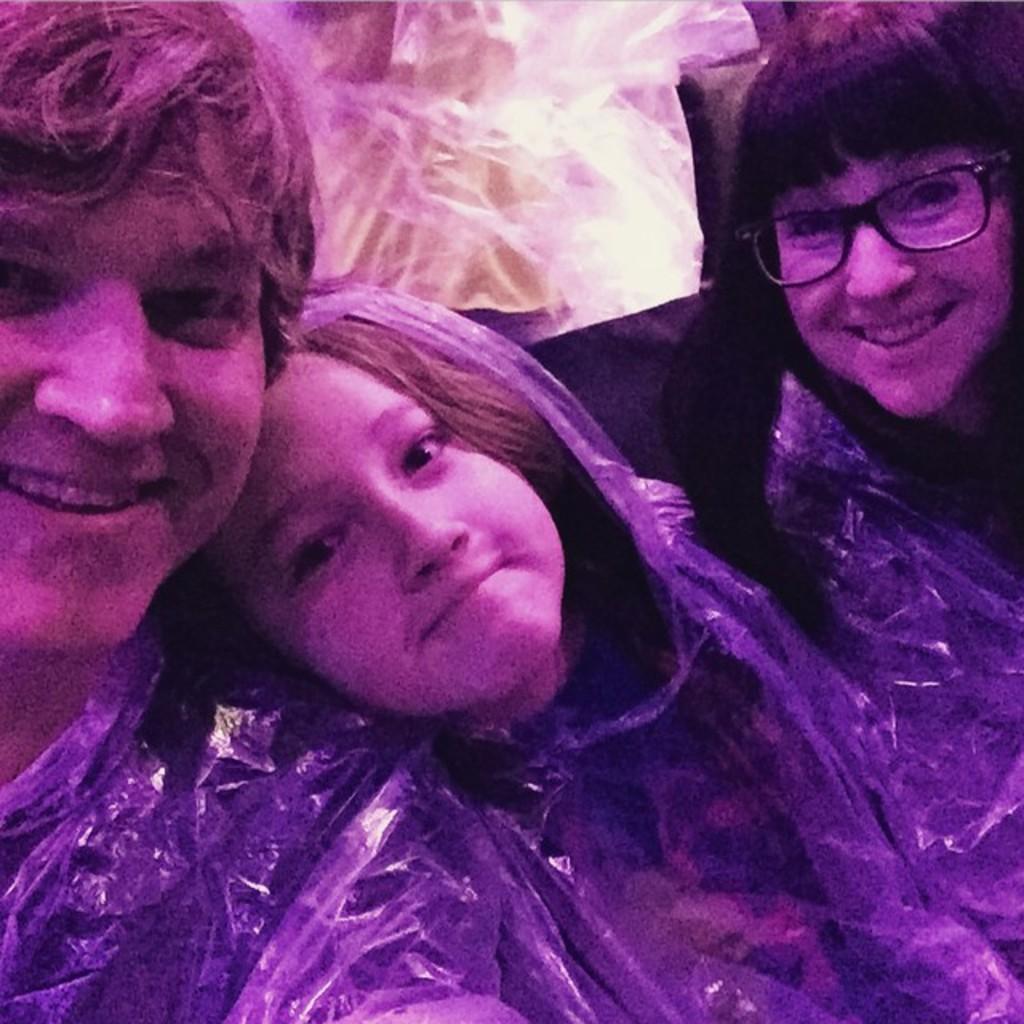Please provide a concise description of this image. In the image few people are sitting and smiling. Behind them few people are standing. 